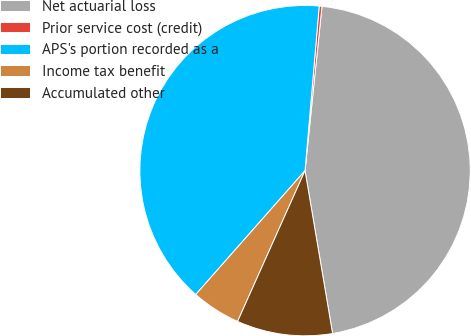<chart> <loc_0><loc_0><loc_500><loc_500><pie_chart><fcel>Net actuarial loss<fcel>Prior service cost (credit)<fcel>APS's portion recorded as a<fcel>Income tax benefit<fcel>Accumulated other<nl><fcel>45.7%<fcel>0.27%<fcel>39.86%<fcel>4.81%<fcel>9.36%<nl></chart> 